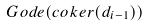Convert formula to latex. <formula><loc_0><loc_0><loc_500><loc_500>G o d e ( c o k e r ( d _ { i - 1 } ) )</formula> 